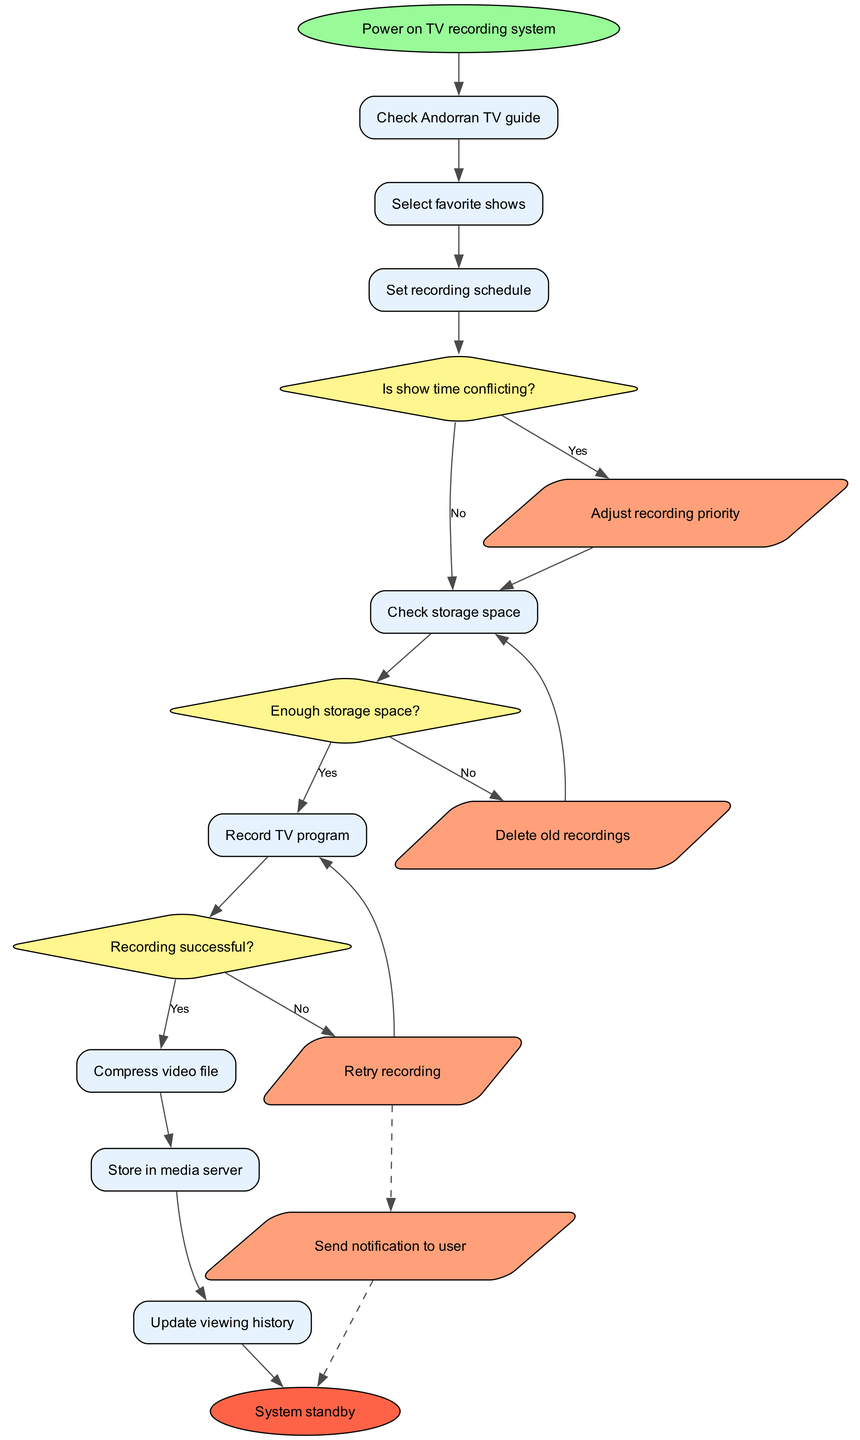What is the first action in the flowchart? The flowchart begins with the action "Power on TV recording system," which is the starting point for all further processes.
Answer: Power on TV recording system How many decision nodes are present in the flowchart? There are three decision nodes in the flowchart, which evaluate conditions regarding recording conflicts, storage space, and recording success.
Answer: 3 What happens if there is not enough storage space? If there’s not enough storage space, the flowchart directs the process to action "Delete old recordings" to free up space for new recordings.
Answer: Delete old recordings What is the final status of the system after completion of the process? The system enters "System standby" after completing all processes in the flowchart, indicating it is ready for the next operation.
Answer: System standby What occurs if the recording is unsuccessful? If the recording is unsuccessful, the flowchart directs to the action "Retry recording," indicating the system attempts to record the program again.
Answer: Retry recording Which node handles user notifications? The node "Send notification to user" handles user notifications, which occurs after a failed recording attempt as indicated by dashed edges stemming from "Retry recording."
Answer: Send notification to user What step follows "Set recording schedule"? The step that follows "Set recording schedule" is a decision node labeled "Is show time conflicting?", determining if there are scheduling issues with the selected shows.
Answer: Is show time conflicting? What is the action taken when a show time is conflicting? When a show time is conflicting, the flowchart indicates "Adjust recording priority" as the course of action to resolve the conflict.
Answer: Adjust recording priority 